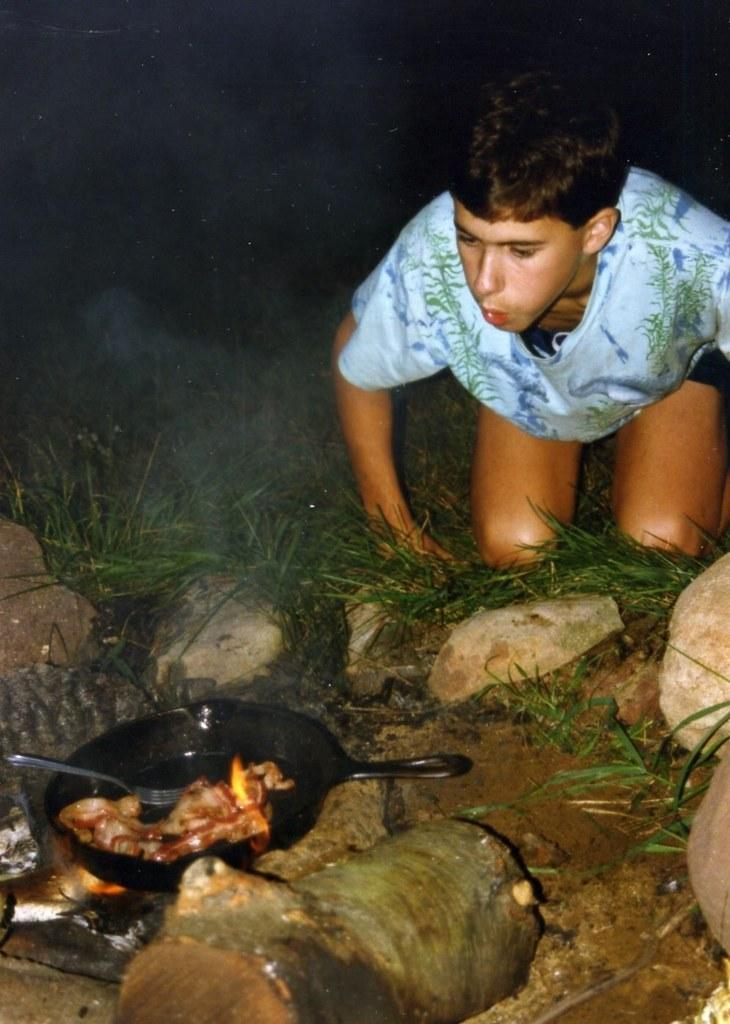Who is present in the image? There is a person in the image. Where is the person located? The person is on the grass. What other objects can be seen in the image? There are stones, a wooden log, a pan on fire with a fork, and food in the pan. What is the lighting condition in the image? The background of the image is dark. Can you tell me how many men are swimming in the image? There are no men swimming in the image; it does not depict any water or swimming activity. 